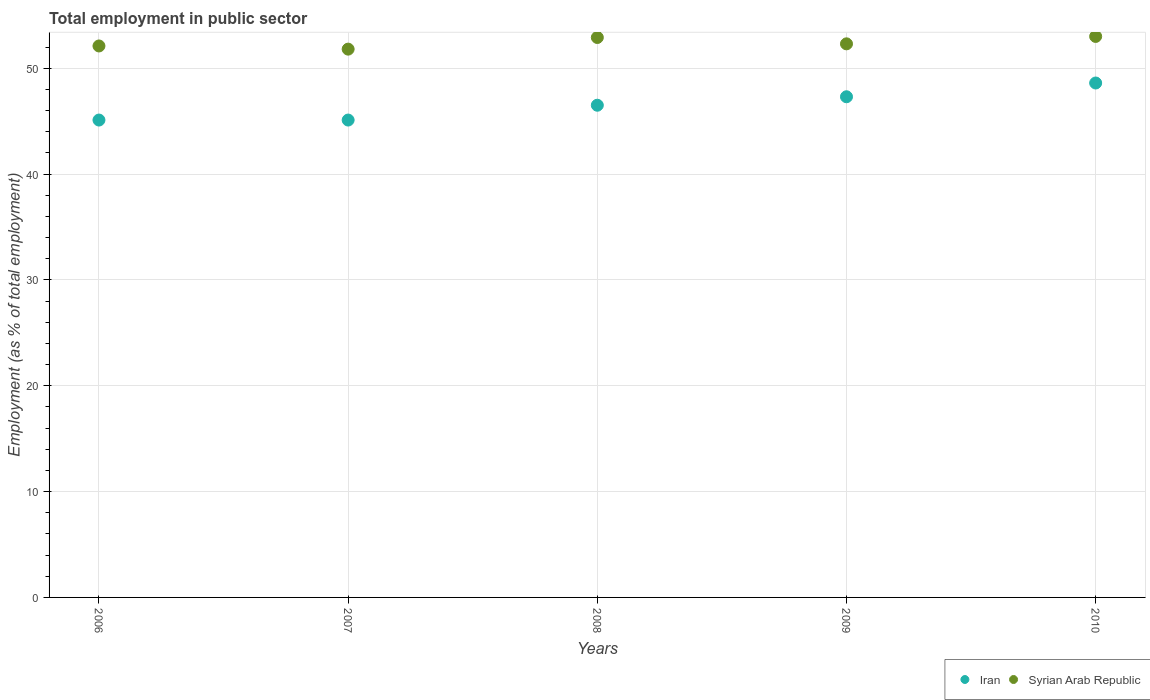What is the employment in public sector in Syrian Arab Republic in 2008?
Ensure brevity in your answer.  52.9. Across all years, what is the minimum employment in public sector in Syrian Arab Republic?
Your response must be concise. 51.8. What is the total employment in public sector in Iran in the graph?
Your answer should be compact. 232.6. What is the difference between the employment in public sector in Syrian Arab Republic in 2006 and that in 2007?
Your answer should be compact. 0.3. What is the difference between the employment in public sector in Syrian Arab Republic in 2006 and the employment in public sector in Iran in 2009?
Your response must be concise. 4.8. What is the average employment in public sector in Iran per year?
Make the answer very short. 46.52. In the year 2007, what is the difference between the employment in public sector in Syrian Arab Republic and employment in public sector in Iran?
Offer a very short reply. 6.7. In how many years, is the employment in public sector in Syrian Arab Republic greater than 18 %?
Offer a terse response. 5. What is the ratio of the employment in public sector in Iran in 2007 to that in 2010?
Make the answer very short. 0.93. What is the difference between the highest and the second highest employment in public sector in Iran?
Provide a short and direct response. 1.3. What is the difference between the highest and the lowest employment in public sector in Syrian Arab Republic?
Offer a very short reply. 1.2. In how many years, is the employment in public sector in Iran greater than the average employment in public sector in Iran taken over all years?
Ensure brevity in your answer.  2. Is the sum of the employment in public sector in Syrian Arab Republic in 2009 and 2010 greater than the maximum employment in public sector in Iran across all years?
Keep it short and to the point. Yes. Does the employment in public sector in Syrian Arab Republic monotonically increase over the years?
Provide a succinct answer. No. Is the employment in public sector in Syrian Arab Republic strictly greater than the employment in public sector in Iran over the years?
Provide a succinct answer. Yes. Is the employment in public sector in Iran strictly less than the employment in public sector in Syrian Arab Republic over the years?
Offer a terse response. Yes. How many dotlines are there?
Make the answer very short. 2. Does the graph contain any zero values?
Keep it short and to the point. No. Does the graph contain grids?
Your answer should be compact. Yes. How many legend labels are there?
Provide a succinct answer. 2. What is the title of the graph?
Provide a succinct answer. Total employment in public sector. Does "Kuwait" appear as one of the legend labels in the graph?
Keep it short and to the point. No. What is the label or title of the X-axis?
Give a very brief answer. Years. What is the label or title of the Y-axis?
Provide a short and direct response. Employment (as % of total employment). What is the Employment (as % of total employment) of Iran in 2006?
Provide a short and direct response. 45.1. What is the Employment (as % of total employment) of Syrian Arab Republic in 2006?
Keep it short and to the point. 52.1. What is the Employment (as % of total employment) of Iran in 2007?
Ensure brevity in your answer.  45.1. What is the Employment (as % of total employment) in Syrian Arab Republic in 2007?
Make the answer very short. 51.8. What is the Employment (as % of total employment) in Iran in 2008?
Offer a very short reply. 46.5. What is the Employment (as % of total employment) of Syrian Arab Republic in 2008?
Provide a short and direct response. 52.9. What is the Employment (as % of total employment) in Iran in 2009?
Your answer should be compact. 47.3. What is the Employment (as % of total employment) in Syrian Arab Republic in 2009?
Provide a short and direct response. 52.3. What is the Employment (as % of total employment) of Iran in 2010?
Offer a terse response. 48.6. Across all years, what is the maximum Employment (as % of total employment) in Iran?
Your answer should be very brief. 48.6. Across all years, what is the minimum Employment (as % of total employment) of Iran?
Make the answer very short. 45.1. Across all years, what is the minimum Employment (as % of total employment) of Syrian Arab Republic?
Make the answer very short. 51.8. What is the total Employment (as % of total employment) of Iran in the graph?
Ensure brevity in your answer.  232.6. What is the total Employment (as % of total employment) of Syrian Arab Republic in the graph?
Your answer should be compact. 262.1. What is the difference between the Employment (as % of total employment) in Iran in 2006 and that in 2007?
Your response must be concise. 0. What is the difference between the Employment (as % of total employment) in Iran in 2006 and that in 2008?
Provide a succinct answer. -1.4. What is the difference between the Employment (as % of total employment) of Syrian Arab Republic in 2006 and that in 2010?
Ensure brevity in your answer.  -0.9. What is the difference between the Employment (as % of total employment) of Iran in 2007 and that in 2008?
Your answer should be compact. -1.4. What is the difference between the Employment (as % of total employment) in Syrian Arab Republic in 2007 and that in 2009?
Your response must be concise. -0.5. What is the difference between the Employment (as % of total employment) in Iran in 2007 and that in 2010?
Provide a succinct answer. -3.5. What is the difference between the Employment (as % of total employment) of Iran in 2008 and that in 2009?
Offer a terse response. -0.8. What is the difference between the Employment (as % of total employment) of Syrian Arab Republic in 2008 and that in 2009?
Your answer should be compact. 0.6. What is the difference between the Employment (as % of total employment) of Iran in 2008 and that in 2010?
Provide a short and direct response. -2.1. What is the difference between the Employment (as % of total employment) in Iran in 2009 and that in 2010?
Offer a very short reply. -1.3. What is the difference between the Employment (as % of total employment) of Iran in 2006 and the Employment (as % of total employment) of Syrian Arab Republic in 2007?
Offer a terse response. -6.7. What is the difference between the Employment (as % of total employment) of Iran in 2006 and the Employment (as % of total employment) of Syrian Arab Republic in 2008?
Provide a succinct answer. -7.8. What is the difference between the Employment (as % of total employment) in Iran in 2006 and the Employment (as % of total employment) in Syrian Arab Republic in 2010?
Your answer should be very brief. -7.9. What is the difference between the Employment (as % of total employment) in Iran in 2007 and the Employment (as % of total employment) in Syrian Arab Republic in 2009?
Offer a terse response. -7.2. What is the difference between the Employment (as % of total employment) of Iran in 2008 and the Employment (as % of total employment) of Syrian Arab Republic in 2009?
Ensure brevity in your answer.  -5.8. What is the difference between the Employment (as % of total employment) of Iran in 2008 and the Employment (as % of total employment) of Syrian Arab Republic in 2010?
Provide a succinct answer. -6.5. What is the difference between the Employment (as % of total employment) in Iran in 2009 and the Employment (as % of total employment) in Syrian Arab Republic in 2010?
Your answer should be compact. -5.7. What is the average Employment (as % of total employment) in Iran per year?
Offer a terse response. 46.52. What is the average Employment (as % of total employment) of Syrian Arab Republic per year?
Provide a succinct answer. 52.42. In the year 2006, what is the difference between the Employment (as % of total employment) of Iran and Employment (as % of total employment) of Syrian Arab Republic?
Your response must be concise. -7. In the year 2007, what is the difference between the Employment (as % of total employment) of Iran and Employment (as % of total employment) of Syrian Arab Republic?
Your answer should be very brief. -6.7. In the year 2008, what is the difference between the Employment (as % of total employment) in Iran and Employment (as % of total employment) in Syrian Arab Republic?
Your answer should be very brief. -6.4. In the year 2009, what is the difference between the Employment (as % of total employment) of Iran and Employment (as % of total employment) of Syrian Arab Republic?
Give a very brief answer. -5. What is the ratio of the Employment (as % of total employment) in Syrian Arab Republic in 2006 to that in 2007?
Your answer should be very brief. 1.01. What is the ratio of the Employment (as % of total employment) of Iran in 2006 to that in 2008?
Keep it short and to the point. 0.97. What is the ratio of the Employment (as % of total employment) in Syrian Arab Republic in 2006 to that in 2008?
Your answer should be very brief. 0.98. What is the ratio of the Employment (as % of total employment) of Iran in 2006 to that in 2009?
Offer a very short reply. 0.95. What is the ratio of the Employment (as % of total employment) of Iran in 2006 to that in 2010?
Provide a short and direct response. 0.93. What is the ratio of the Employment (as % of total employment) of Iran in 2007 to that in 2008?
Make the answer very short. 0.97. What is the ratio of the Employment (as % of total employment) of Syrian Arab Republic in 2007 to that in 2008?
Keep it short and to the point. 0.98. What is the ratio of the Employment (as % of total employment) of Iran in 2007 to that in 2009?
Provide a succinct answer. 0.95. What is the ratio of the Employment (as % of total employment) in Syrian Arab Republic in 2007 to that in 2009?
Ensure brevity in your answer.  0.99. What is the ratio of the Employment (as % of total employment) in Iran in 2007 to that in 2010?
Ensure brevity in your answer.  0.93. What is the ratio of the Employment (as % of total employment) of Syrian Arab Republic in 2007 to that in 2010?
Make the answer very short. 0.98. What is the ratio of the Employment (as % of total employment) of Iran in 2008 to that in 2009?
Your answer should be compact. 0.98. What is the ratio of the Employment (as % of total employment) of Syrian Arab Republic in 2008 to that in 2009?
Your answer should be compact. 1.01. What is the ratio of the Employment (as % of total employment) in Iran in 2008 to that in 2010?
Offer a terse response. 0.96. What is the ratio of the Employment (as % of total employment) in Iran in 2009 to that in 2010?
Make the answer very short. 0.97. What is the ratio of the Employment (as % of total employment) in Syrian Arab Republic in 2009 to that in 2010?
Your answer should be very brief. 0.99. What is the difference between the highest and the second highest Employment (as % of total employment) in Iran?
Give a very brief answer. 1.3. What is the difference between the highest and the second highest Employment (as % of total employment) of Syrian Arab Republic?
Ensure brevity in your answer.  0.1. What is the difference between the highest and the lowest Employment (as % of total employment) of Iran?
Provide a short and direct response. 3.5. 